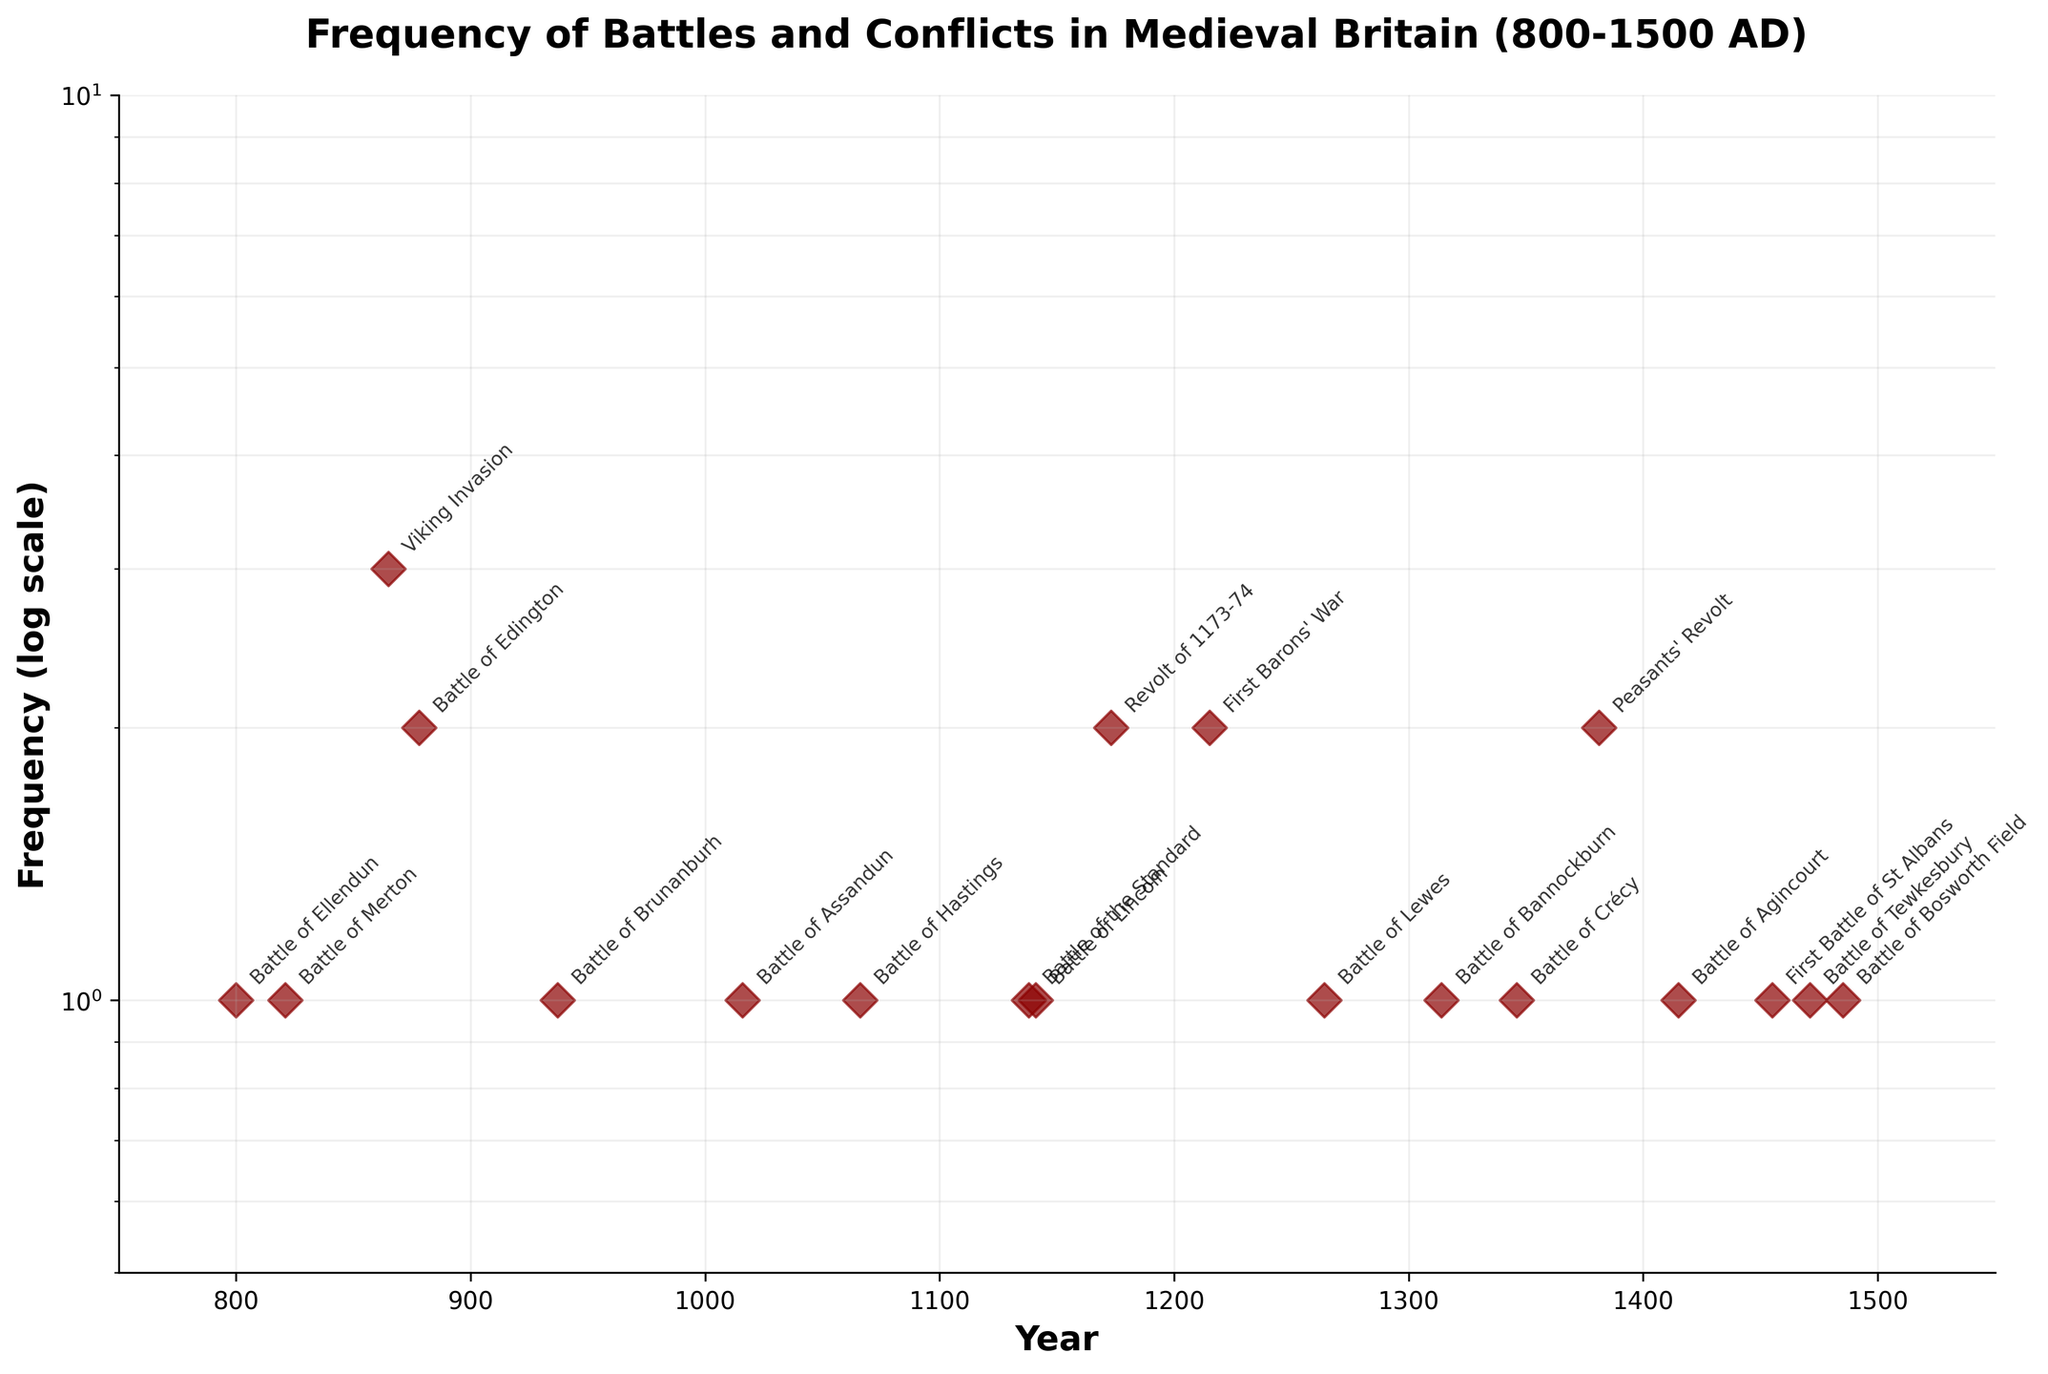What is the title of the plot? The title of the plot can be seen at the top of the figure, written in bold. It reads "Frequency of Battles and Conflicts in Medieval Britain (800-1500 AD)."
Answer: Frequency of Battles and Conflicts in Medieval Britain (800-1500 AD) What is the scale used for the y-axis? The y-axis is labeled "Frequency (log scale)" indicating that it uses a logarithmic scale. This information is also supported by the log nature of the ticks on the y-axis that are all multiples of 10.
Answer: Logarithmic How many events have a frequency greater than 1? By observing the plot, the frequencies of events can be identified. The events that have a frequency greater than 1 are the Viking Invasion (3), Battle of Edington (2), Revolt of 1173-74 (2), First Barons' War (2), and Peasants' Revolt (2). That makes 5 events in total.
Answer: 5 What are the events with the highest frequency, and what is this frequency? The highest frequency observed on the plot is 3, marked by the Viking Invasion.
Answer: Viking Invasion, 3 Which battle occurred in 1066? The plot annotates every marker with the event name. The marker for the year 1066 is labeled "Battle of Hastings."
Answer: Battle of Hastings How does the frequency of the Viking Invasion compare to the frequency of the Battle of Hastings? The plot shows the Viking Invasion with a frequency of 3 and the Battle of Hastings with a frequency of 1. Thus, the frequency of the Viking Invasion is greater than the frequency of the Battle of Hastings.
Answer: Viking Invasion > Battle of Hastings What is the general trend observed between years and the frequency of battles? By looking at the overall plot, it can be observed that most battles have a frequency of 1, sporadically punctuated by some events with higher frequencies. This suggests there is no clear increasing or decreasing trend over time.
Answer: Most events have a frequency of 1 Which events occurred during the 15th century (1401-1500)? Reviewing the annotations corresponding to the 15th-century years, we observe three events: the Battle of Agincourt (1415), the First Battle of St Albans (1455), and the Battle of Tewkesbury (1471).
Answer: Battle of Agincourt, First Battle of St Albans, Battle of Tewkesbury What is the frequency range displayed on the y-axis? The y-axis of the plot displays frequencies on a logarithmic scale, ranging from 0.5 to 10.
Answer: 0.5 to 10 